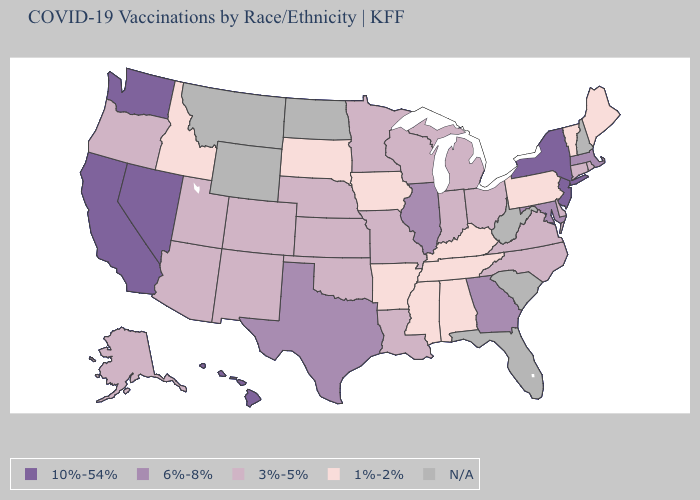Does Alabama have the highest value in the USA?
Be succinct. No. Does New Jersey have the highest value in the Northeast?
Keep it brief. Yes. What is the value of Delaware?
Write a very short answer. 3%-5%. Which states have the highest value in the USA?
Give a very brief answer. California, Hawaii, Nevada, New Jersey, New York, Washington. Name the states that have a value in the range 6%-8%?
Concise answer only. Georgia, Illinois, Maryland, Massachusetts, Texas. Name the states that have a value in the range 6%-8%?
Answer briefly. Georgia, Illinois, Maryland, Massachusetts, Texas. What is the value of New York?
Quick response, please. 10%-54%. What is the value of Mississippi?
Quick response, please. 1%-2%. Name the states that have a value in the range N/A?
Concise answer only. Florida, Montana, New Hampshire, North Dakota, South Carolina, West Virginia, Wyoming. Name the states that have a value in the range 3%-5%?
Quick response, please. Alaska, Arizona, Colorado, Connecticut, Delaware, Indiana, Kansas, Louisiana, Michigan, Minnesota, Missouri, Nebraska, New Mexico, North Carolina, Ohio, Oklahoma, Oregon, Rhode Island, Utah, Virginia, Wisconsin. Among the states that border Nevada , which have the lowest value?
Keep it brief. Idaho. What is the value of Ohio?
Give a very brief answer. 3%-5%. Which states have the highest value in the USA?
Give a very brief answer. California, Hawaii, Nevada, New Jersey, New York, Washington. Does Ohio have the highest value in the USA?
Be succinct. No. What is the value of Kentucky?
Quick response, please. 1%-2%. 